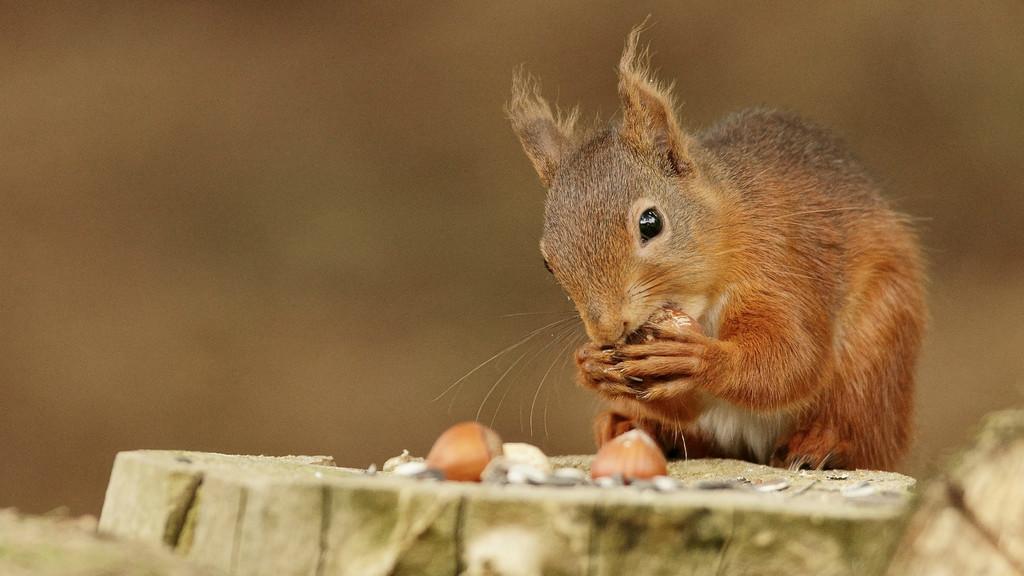Please provide a concise description of this image. On the right side of the image we can see a fox squirrel eating some food item. At the bottom of the image we can see wood and some food item. In the background the image is blur. 